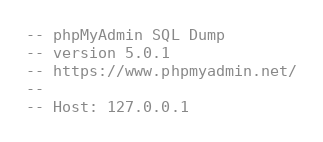<code> <loc_0><loc_0><loc_500><loc_500><_SQL_>-- phpMyAdmin SQL Dump
-- version 5.0.1
-- https://www.phpmyadmin.net/
--
-- Host: 127.0.0.1</code> 